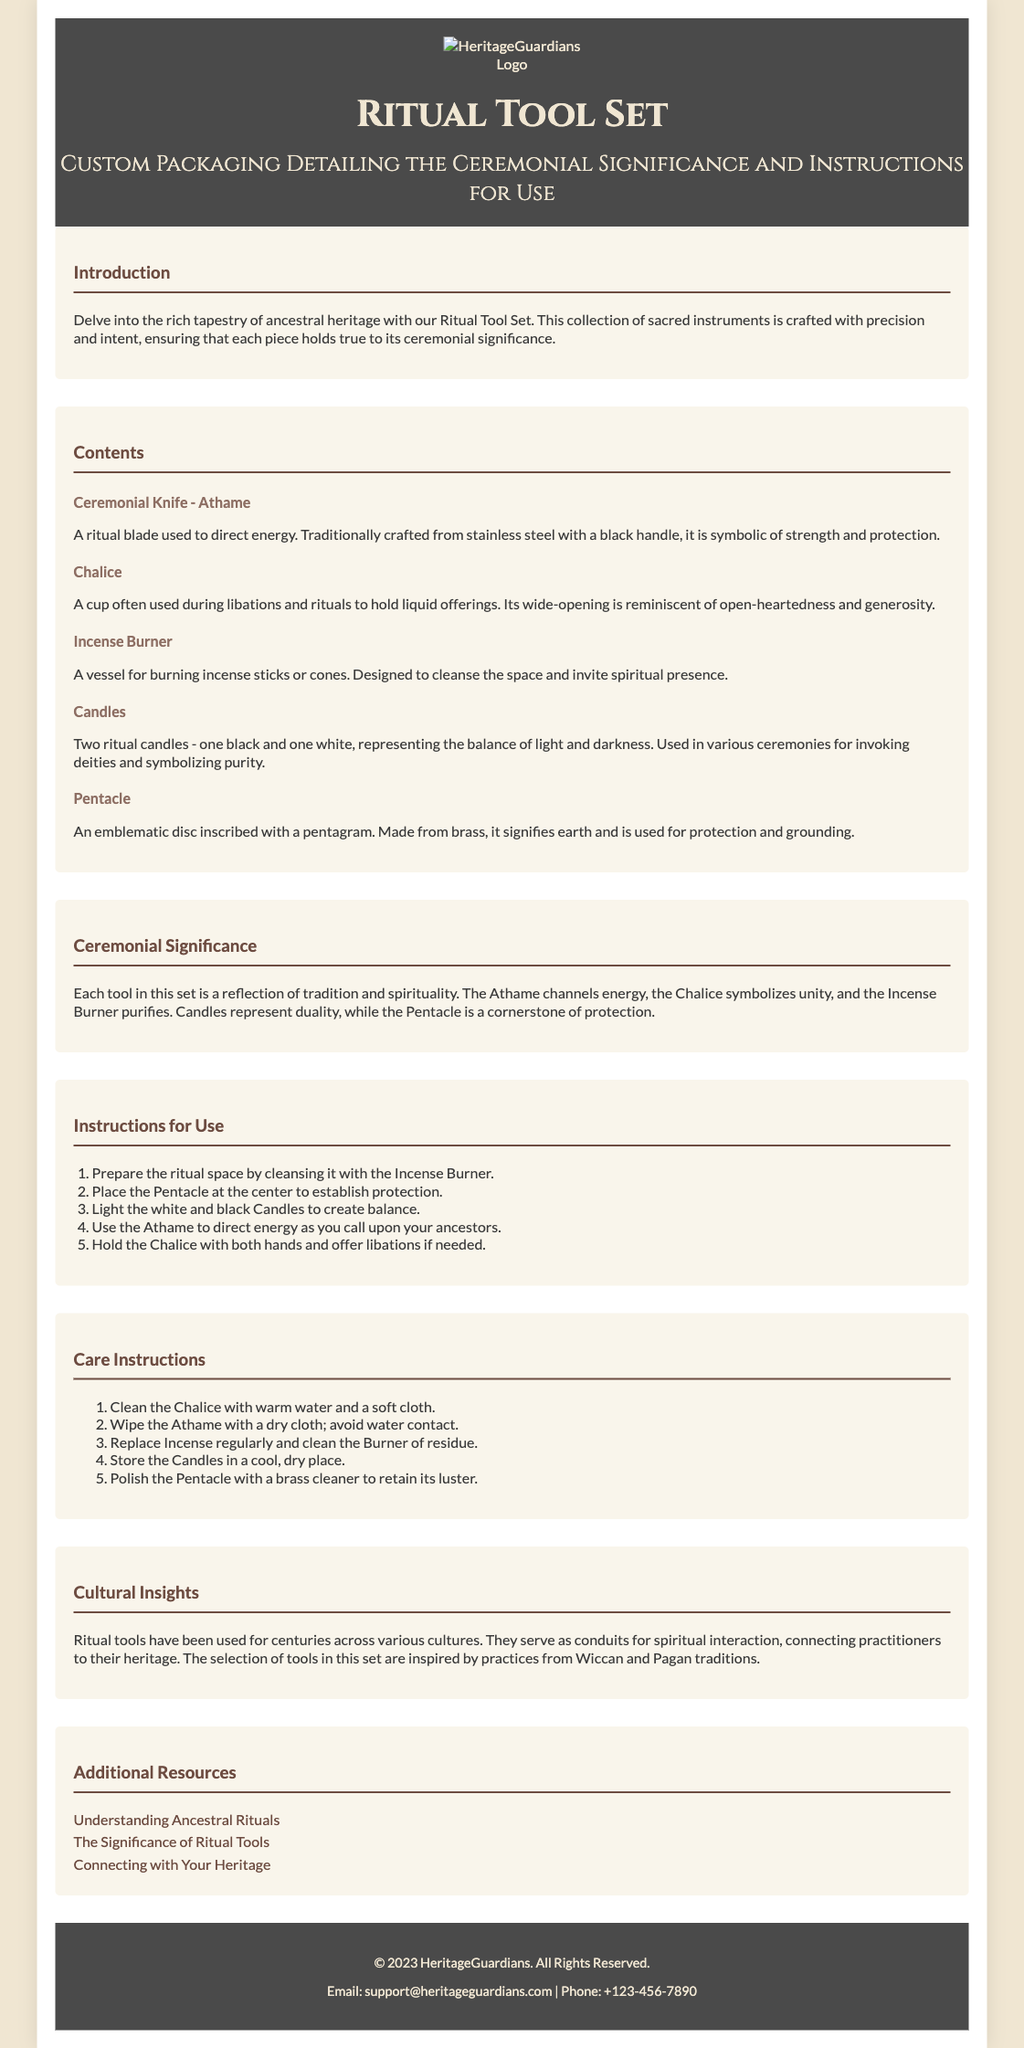what is the title of the product? The title of the product is found in the header section of the document.
Answer: Ritual Tool Set how many items are listed in the contents? The number of items is counted in the "Contents" section.
Answer: Five what does the Chalice symbolize? The symbolism of the Chalice is explained in the description under "Contents."
Answer: Unity what is the color of the Athame handle? The color of the Athame handle can be found in its description.
Answer: Black which two colors are used for the ritual candles? The colors of the candles are specified in their description under "Contents."
Answer: Black and white what is the first step in the instructions for use? The first step is outlined clearly in the "Instructions for Use" section.
Answer: Prepare the ritual space by cleansing it with the Incense Burner which culture inspired the selection of tools in the set? The cultural inspiration is mentioned in the "Cultural Insights" section.
Answer: Wiccan and Pagan traditions what is the purpose of the Incense Burner? The purpose of the Incense Burner is stated in its description.
Answer: To cleanse the space and invite spiritual presence what should you do to clean the Athame? The cleaning instruction for the Athame is given in the "Care Instructions" section.
Answer: Wipe with a dry cloth; avoid water contact 